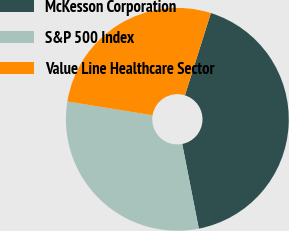<chart> <loc_0><loc_0><loc_500><loc_500><pie_chart><fcel>McKesson Corporation<fcel>S&P 500 Index<fcel>Value Line Healthcare Sector<nl><fcel>42.05%<fcel>30.64%<fcel>27.3%<nl></chart> 